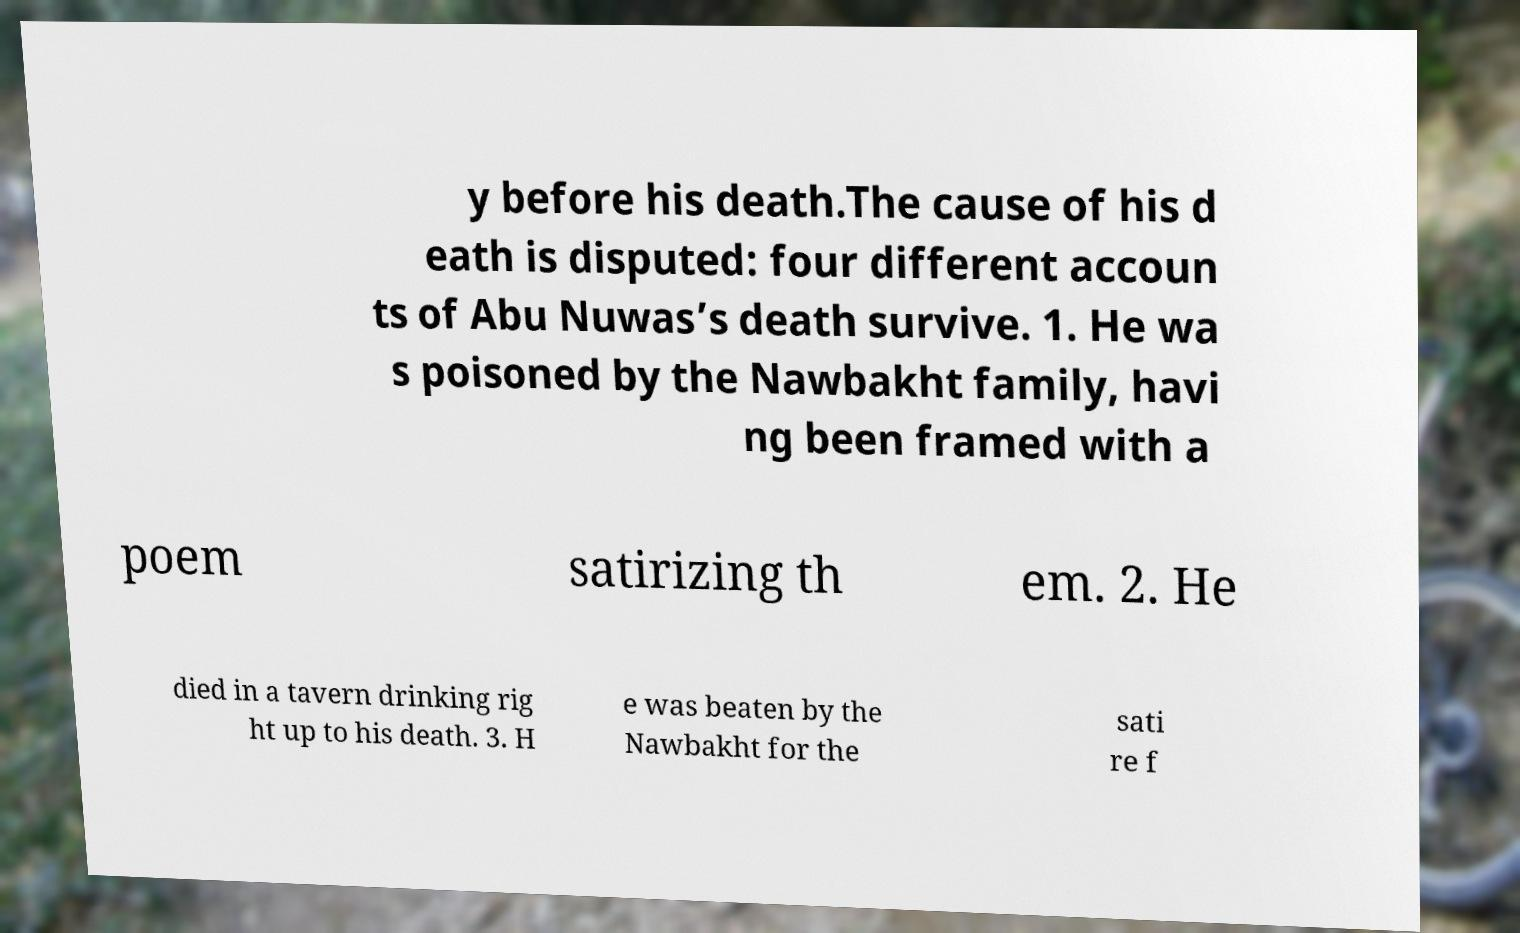Can you read and provide the text displayed in the image?This photo seems to have some interesting text. Can you extract and type it out for me? y before his death.The cause of his d eath is disputed: four different accoun ts of Abu Nuwas’s death survive. 1. He wa s poisoned by the Nawbakht family, havi ng been framed with a poem satirizing th em. 2. He died in a tavern drinking rig ht up to his death. 3. H e was beaten by the Nawbakht for the sati re f 